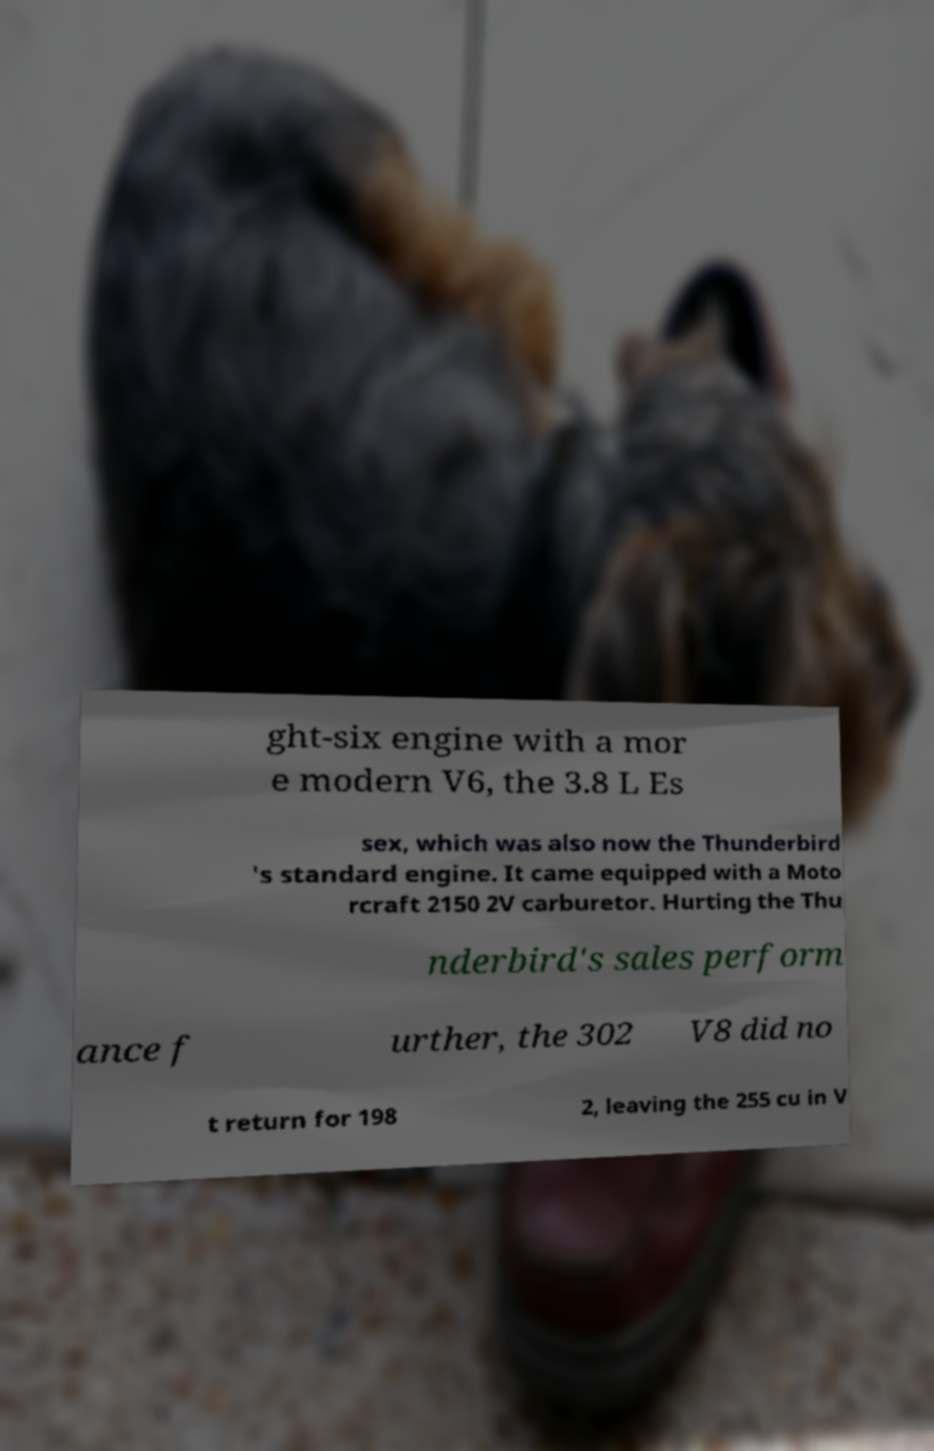Can you accurately transcribe the text from the provided image for me? ght-six engine with a mor e modern V6, the 3.8 L Es sex, which was also now the Thunderbird 's standard engine. It came equipped with a Moto rcraft 2150 2V carburetor. Hurting the Thu nderbird's sales perform ance f urther, the 302 V8 did no t return for 198 2, leaving the 255 cu in V 